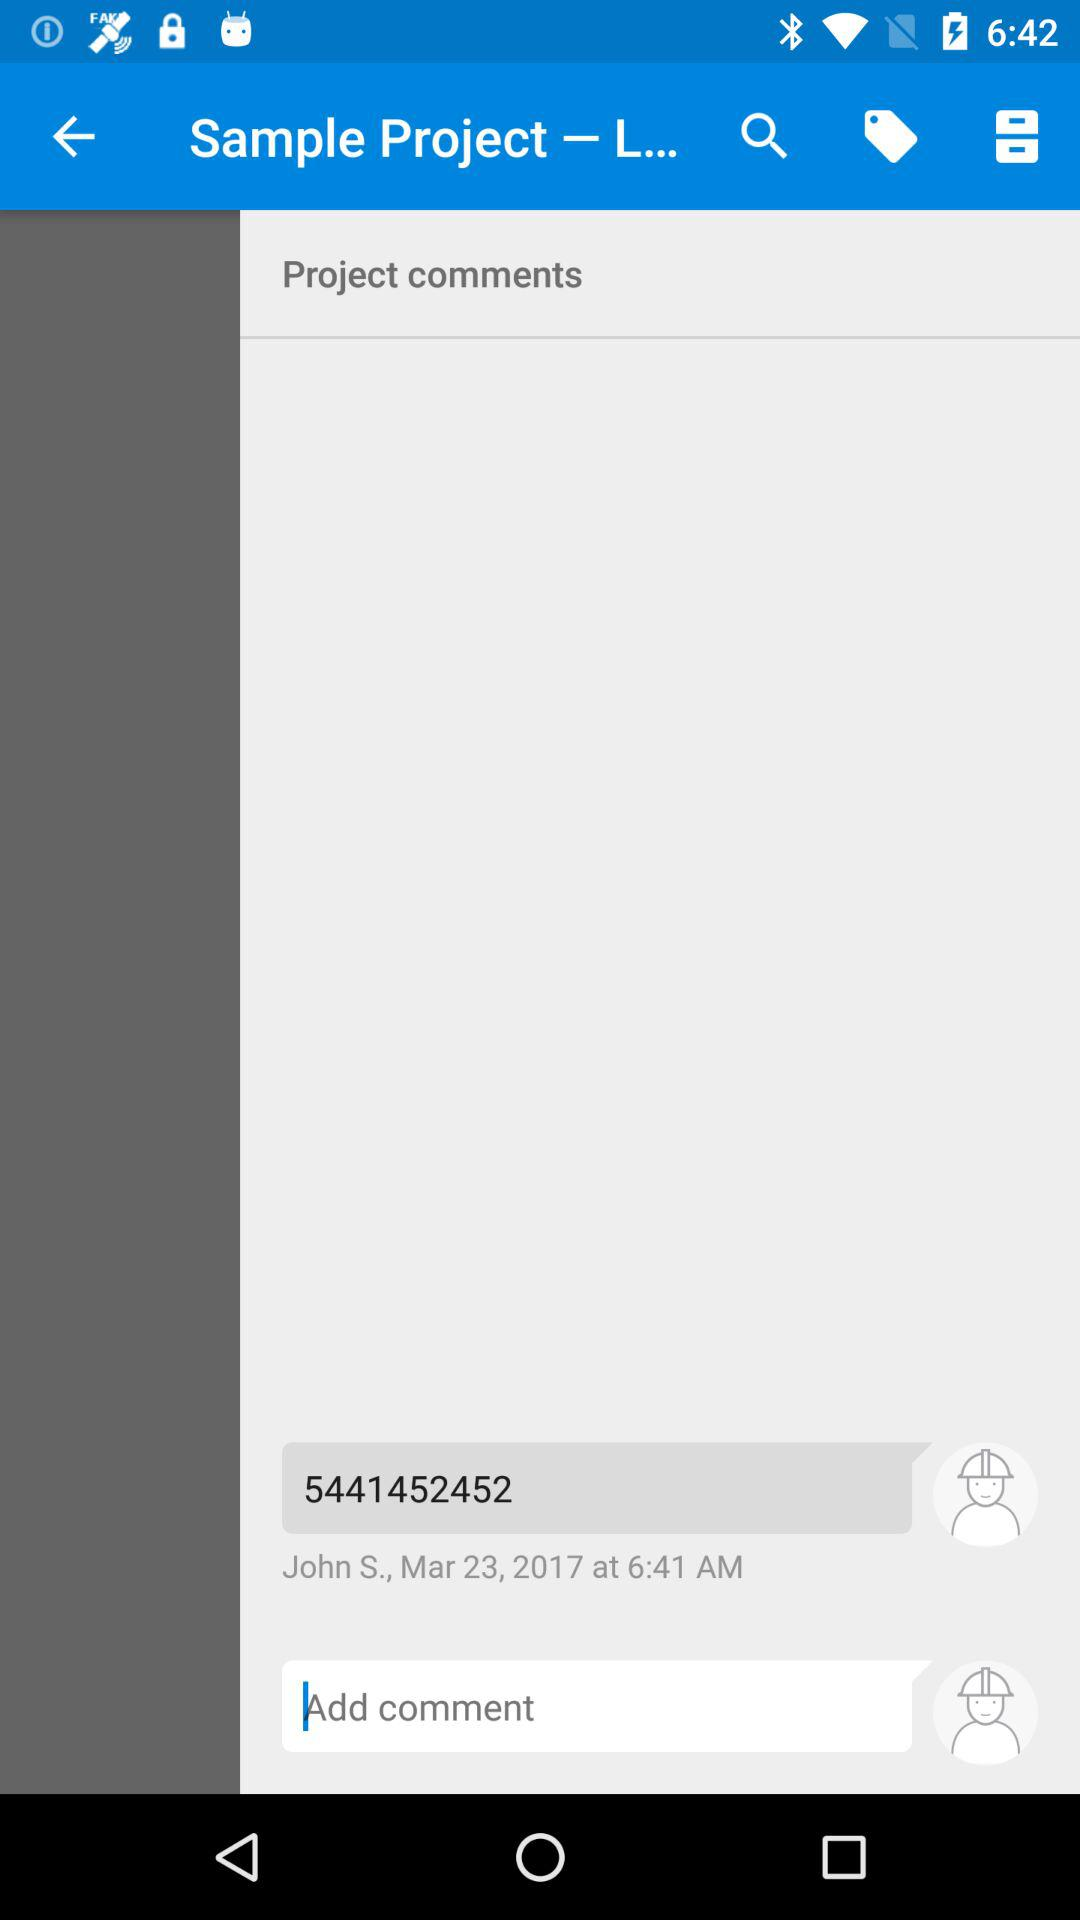What is the comment from John S? The comment from John S is 5441452452. 